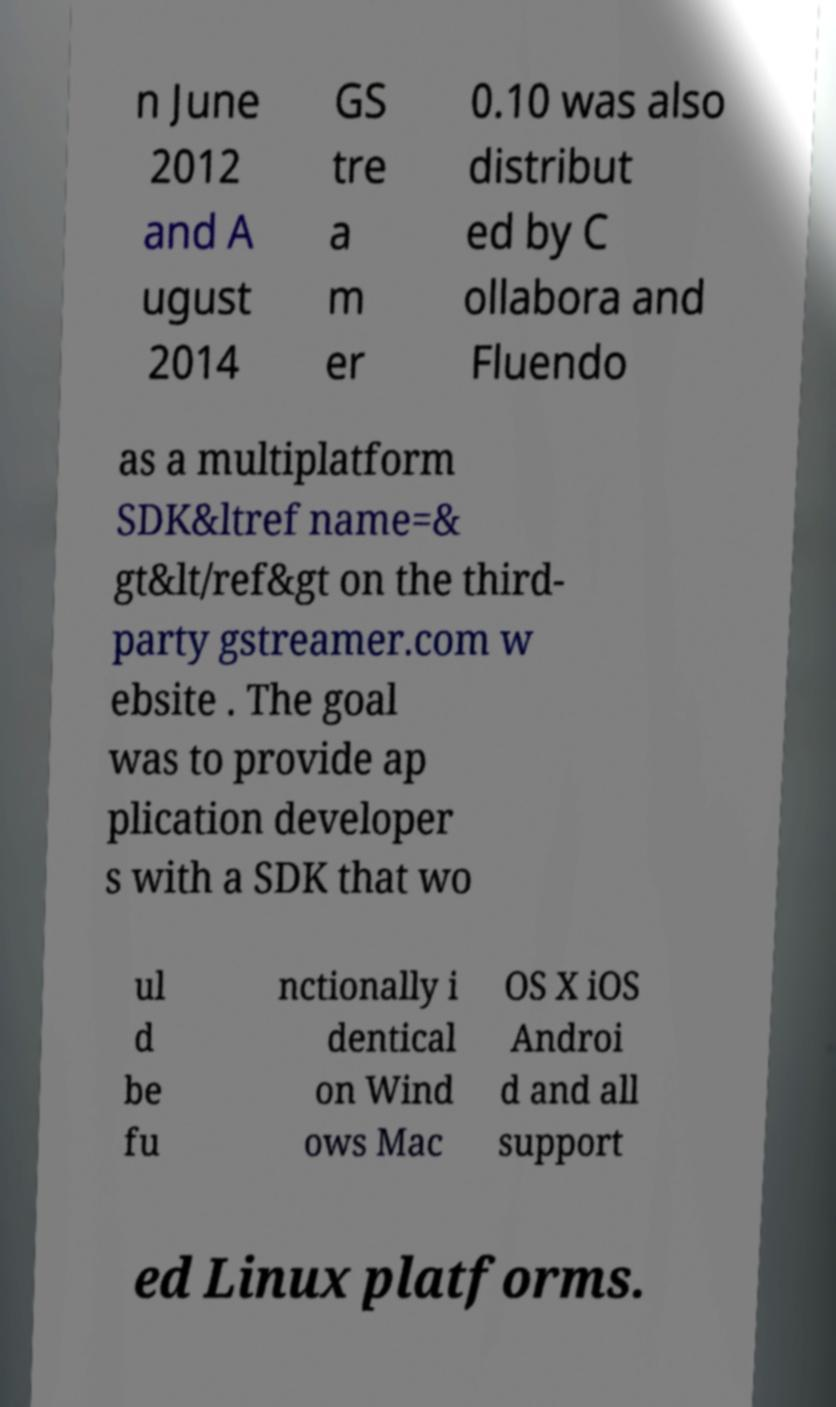Can you read and provide the text displayed in the image?This photo seems to have some interesting text. Can you extract and type it out for me? n June 2012 and A ugust 2014 GS tre a m er 0.10 was also distribut ed by C ollabora and Fluendo as a multiplatform SDK&ltref name=& gt&lt/ref&gt on the third- party gstreamer.com w ebsite . The goal was to provide ap plication developer s with a SDK that wo ul d be fu nctionally i dentical on Wind ows Mac OS X iOS Androi d and all support ed Linux platforms. 